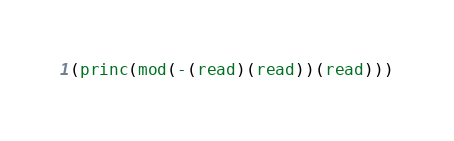Convert code to text. <code><loc_0><loc_0><loc_500><loc_500><_Lisp_>(princ(mod(-(read)(read))(read)))</code> 